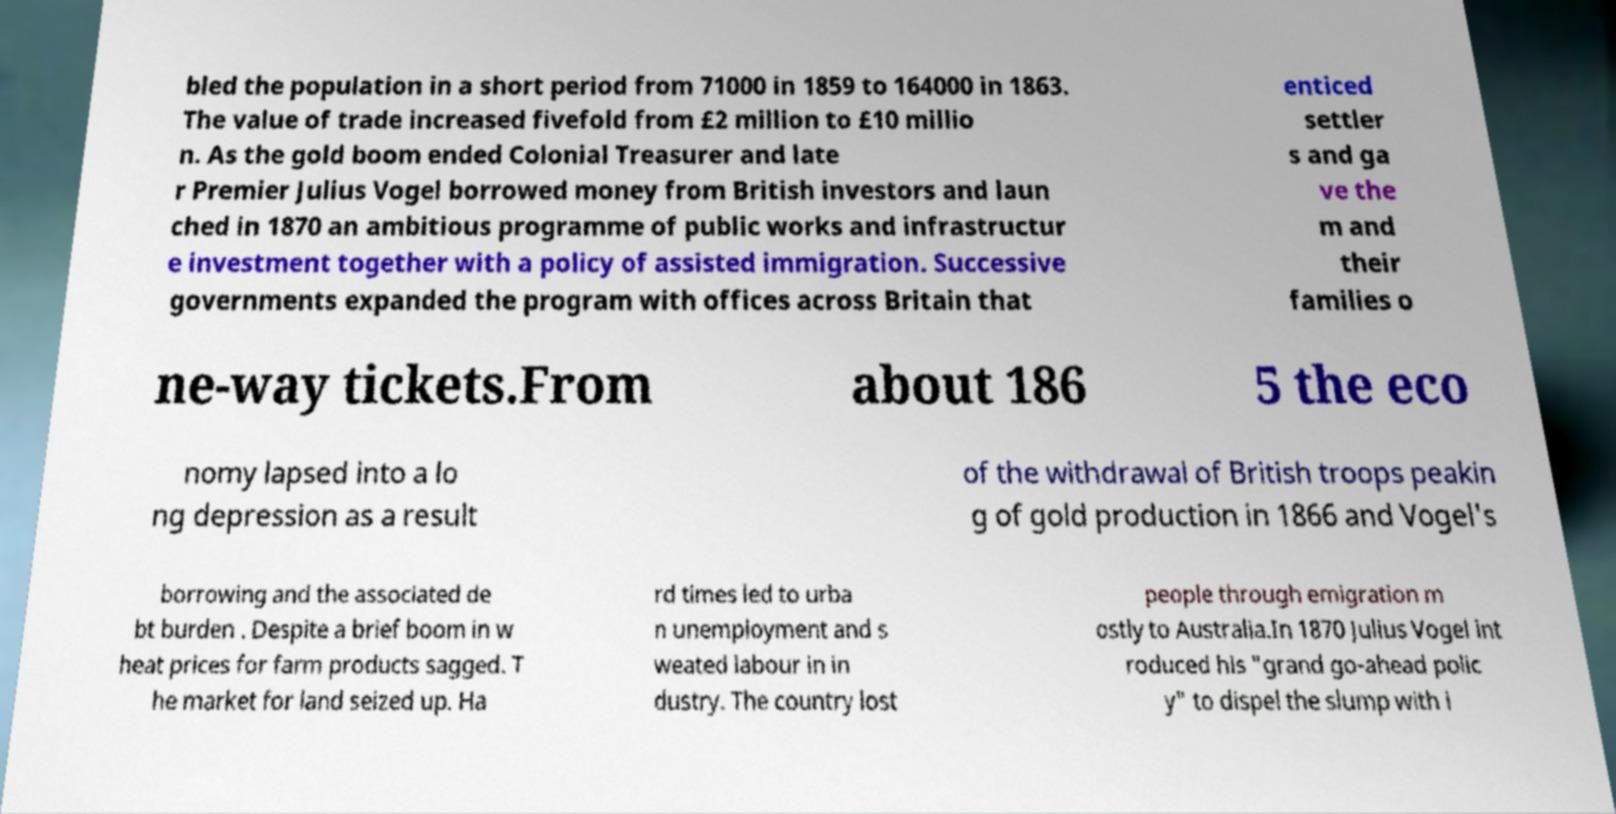Please read and relay the text visible in this image. What does it say? bled the population in a short period from 71000 in 1859 to 164000 in 1863. The value of trade increased fivefold from £2 million to £10 millio n. As the gold boom ended Colonial Treasurer and late r Premier Julius Vogel borrowed money from British investors and laun ched in 1870 an ambitious programme of public works and infrastructur e investment together with a policy of assisted immigration. Successive governments expanded the program with offices across Britain that enticed settler s and ga ve the m and their families o ne-way tickets.From about 186 5 the eco nomy lapsed into a lo ng depression as a result of the withdrawal of British troops peakin g of gold production in 1866 and Vogel's borrowing and the associated de bt burden . Despite a brief boom in w heat prices for farm products sagged. T he market for land seized up. Ha rd times led to urba n unemployment and s weated labour in in dustry. The country lost people through emigration m ostly to Australia.In 1870 Julius Vogel int roduced his "grand go-ahead polic y" to dispel the slump with i 